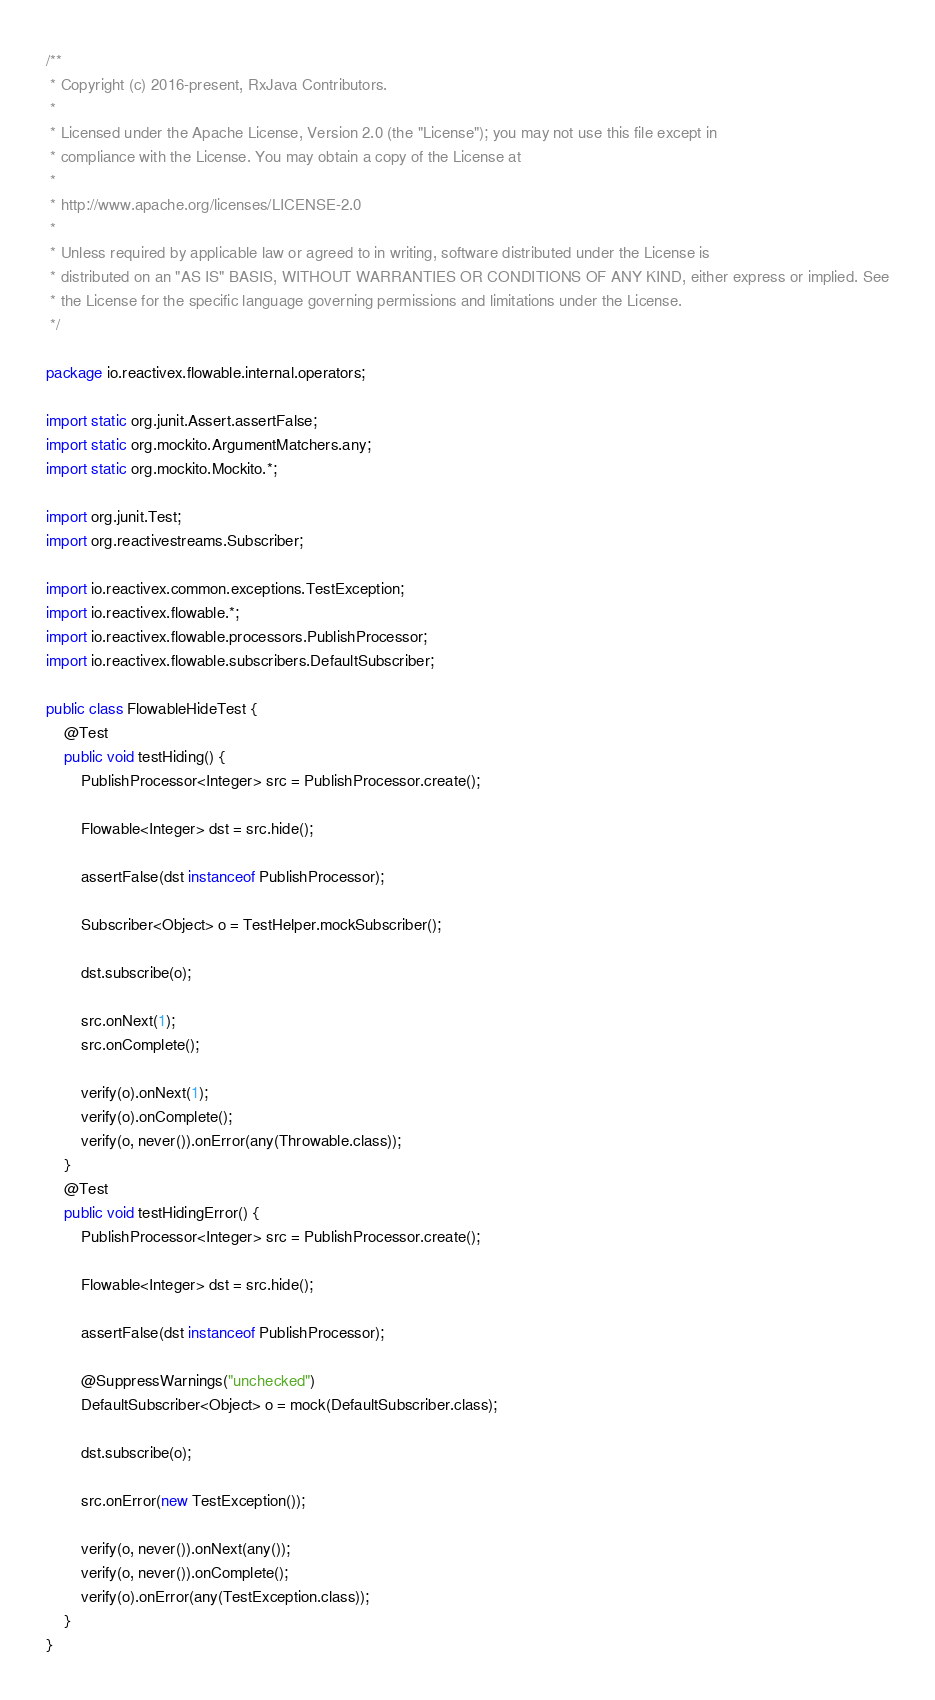Convert code to text. <code><loc_0><loc_0><loc_500><loc_500><_Java_>/**
 * Copyright (c) 2016-present, RxJava Contributors.
 *
 * Licensed under the Apache License, Version 2.0 (the "License"); you may not use this file except in
 * compliance with the License. You may obtain a copy of the License at
 *
 * http://www.apache.org/licenses/LICENSE-2.0
 *
 * Unless required by applicable law or agreed to in writing, software distributed under the License is
 * distributed on an "AS IS" BASIS, WITHOUT WARRANTIES OR CONDITIONS OF ANY KIND, either express or implied. See
 * the License for the specific language governing permissions and limitations under the License.
 */

package io.reactivex.flowable.internal.operators;

import static org.junit.Assert.assertFalse;
import static org.mockito.ArgumentMatchers.any;
import static org.mockito.Mockito.*;

import org.junit.Test;
import org.reactivestreams.Subscriber;

import io.reactivex.common.exceptions.TestException;
import io.reactivex.flowable.*;
import io.reactivex.flowable.processors.PublishProcessor;
import io.reactivex.flowable.subscribers.DefaultSubscriber;

public class FlowableHideTest {
    @Test
    public void testHiding() {
        PublishProcessor<Integer> src = PublishProcessor.create();

        Flowable<Integer> dst = src.hide();

        assertFalse(dst instanceof PublishProcessor);

        Subscriber<Object> o = TestHelper.mockSubscriber();

        dst.subscribe(o);

        src.onNext(1);
        src.onComplete();

        verify(o).onNext(1);
        verify(o).onComplete();
        verify(o, never()).onError(any(Throwable.class));
    }
    @Test
    public void testHidingError() {
        PublishProcessor<Integer> src = PublishProcessor.create();

        Flowable<Integer> dst = src.hide();

        assertFalse(dst instanceof PublishProcessor);

        @SuppressWarnings("unchecked")
        DefaultSubscriber<Object> o = mock(DefaultSubscriber.class);

        dst.subscribe(o);

        src.onError(new TestException());

        verify(o, never()).onNext(any());
        verify(o, never()).onComplete();
        verify(o).onError(any(TestException.class));
    }
}
</code> 